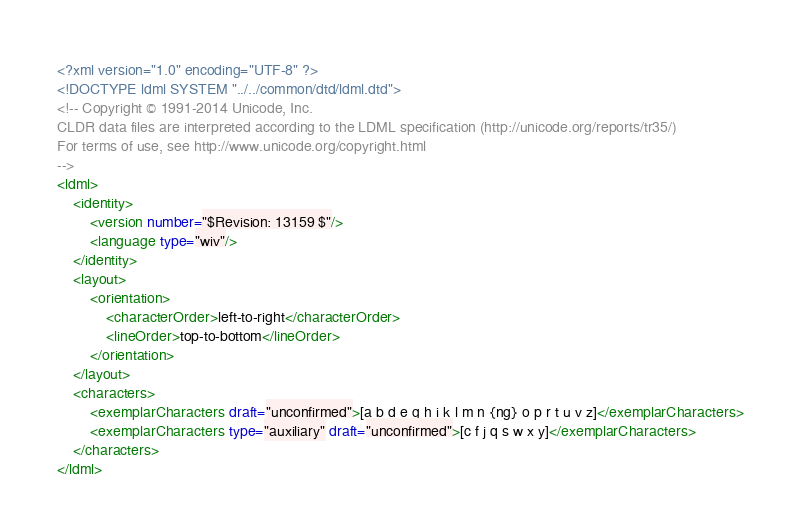Convert code to text. <code><loc_0><loc_0><loc_500><loc_500><_XML_><?xml version="1.0" encoding="UTF-8" ?>
<!DOCTYPE ldml SYSTEM "../../common/dtd/ldml.dtd">
<!-- Copyright © 1991-2014 Unicode, Inc.
CLDR data files are interpreted according to the LDML specification (http://unicode.org/reports/tr35/)
For terms of use, see http://www.unicode.org/copyright.html
-->
<ldml>
	<identity>
		<version number="$Revision: 13159 $"/>
		<language type="wiv"/>
	</identity>
	<layout>
		<orientation>
			<characterOrder>left-to-right</characterOrder>
			<lineOrder>top-to-bottom</lineOrder>
		</orientation>
	</layout>
	<characters>
		<exemplarCharacters draft="unconfirmed">[a b d e g h i k l m n {ng} o p r t u v z]</exemplarCharacters>
		<exemplarCharacters type="auxiliary" draft="unconfirmed">[c f j q s w x y]</exemplarCharacters>
	</characters>
</ldml>
</code> 